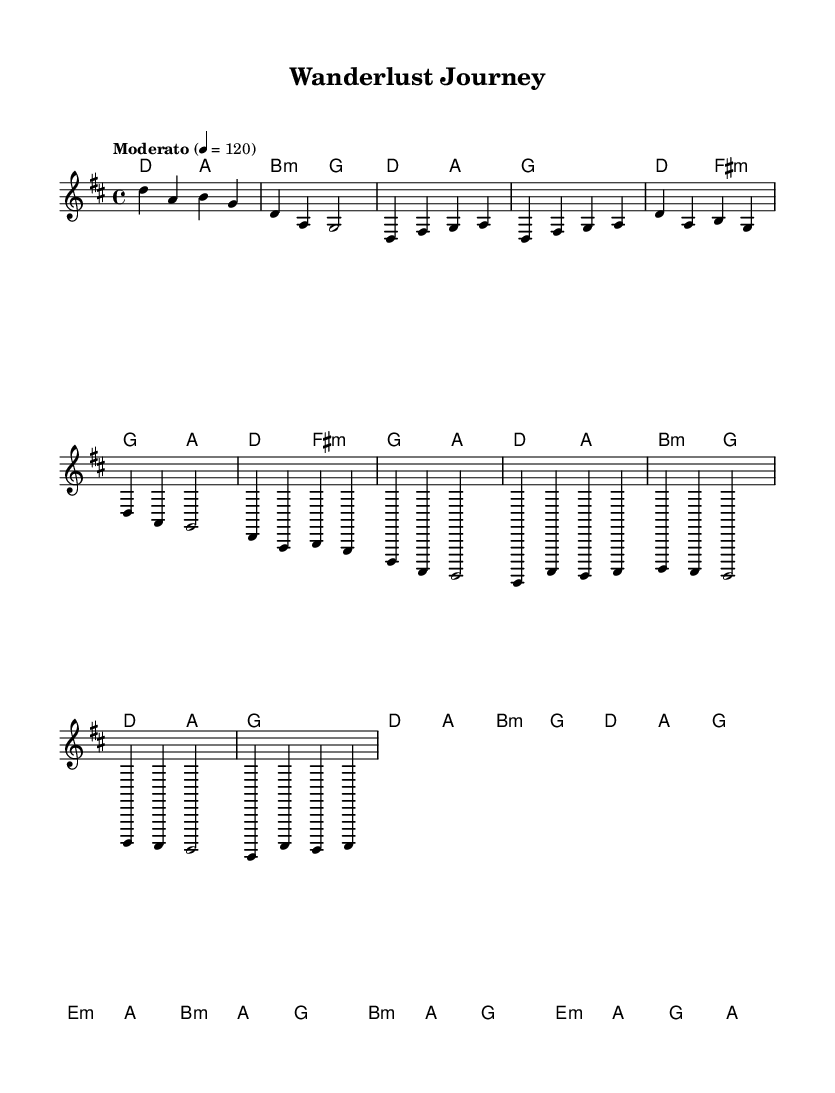What is the key signature of this music? The key signature is D major, which has two sharps: F# and C#. This is determined from the global section of the code where it specifies "\key d \major".
Answer: D major What is the time signature of this music? The time signature is 4/4, which means there are four beats in each measure and the quarter note gets the beat. This can be found in the global section where it states "\time 4/4".
Answer: 4/4 What is the tempo marking for this piece? The tempo marking is "Moderato" which indicates a moderate speed. This is indicated by the tempo line in the global section, where it states "\tempo 'Moderato' 4 = 120”.
Answer: Moderato How many measures are in the chorus section? There are four measures in the chorus section. This can be counted directly from the coded lyrics associated with the melody as it clearly separates each part of the song with distinct measures.
Answer: 4 What is the starting note of the solo section? The starting note of the solo section is D. This is found in the melody section where the solo begins with "d4 a4 b4 g4", indicating that D is the first note played.
Answer: D What is the lyric of the last line in the verse? The last line in the verse is "Free -- dom's cal -- ling, hold on tight". This can be identified by looking at the lyrics provided in the verseOne section, focusing on the last phrase.
Answer: Free -- dom's cal -- ling, hold on tight How does the melody progress in the chorus compared to the verse? The melody in the chorus has a similar structure but a different emotional intensity and repetition, moving through the same notes but emphasizing the adventure theme. This can be derived from comparing the specific notes and their rhythmic qualities in both sections, as well as lyrical content that denotes a shift in emotional context.
Answer: Emphasizes adventure 